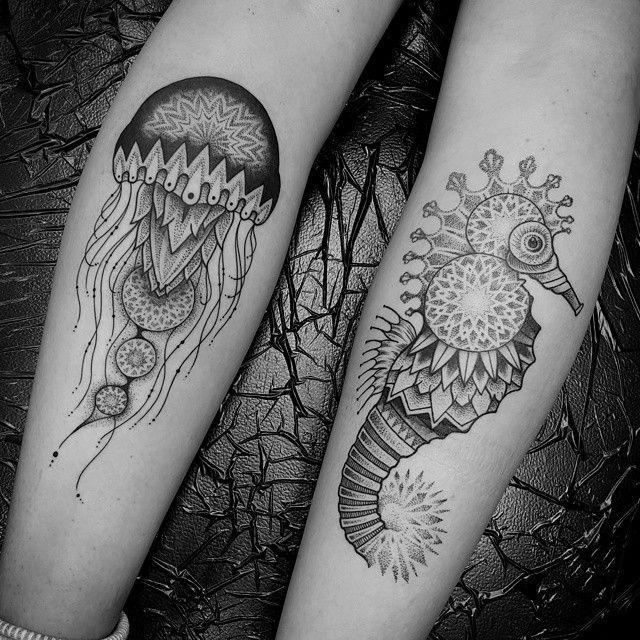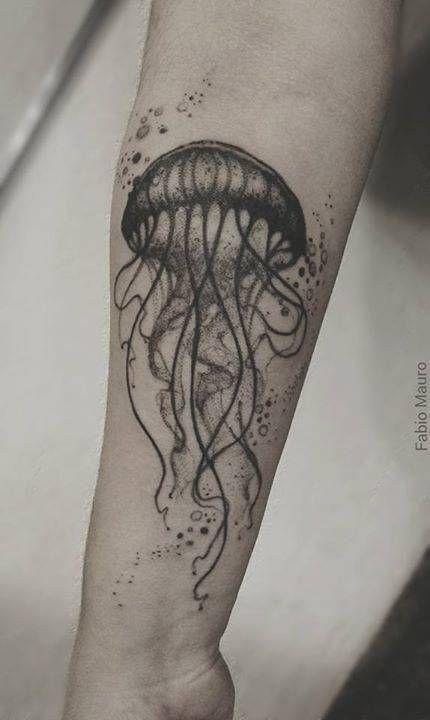The first image is the image on the left, the second image is the image on the right. Given the left and right images, does the statement "Each image shows exactly one tattoo on a person's bare skin, each image an elaborate jelly fish design with long tendrils inked in black." hold true? Answer yes or no. No. 